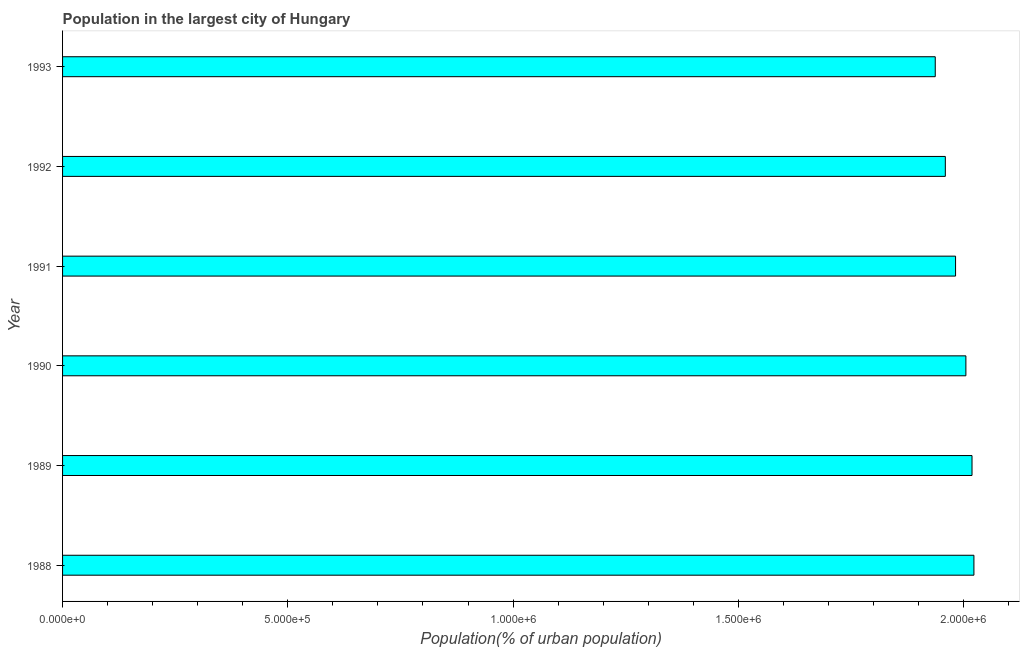Does the graph contain any zero values?
Offer a very short reply. No. Does the graph contain grids?
Ensure brevity in your answer.  No. What is the title of the graph?
Provide a succinct answer. Population in the largest city of Hungary. What is the label or title of the X-axis?
Give a very brief answer. Population(% of urban population). What is the population in largest city in 1991?
Your answer should be very brief. 1.98e+06. Across all years, what is the maximum population in largest city?
Offer a terse response. 2.02e+06. Across all years, what is the minimum population in largest city?
Offer a terse response. 1.94e+06. In which year was the population in largest city minimum?
Offer a terse response. 1993. What is the sum of the population in largest city?
Your response must be concise. 1.19e+07. What is the difference between the population in largest city in 1991 and 1992?
Your answer should be very brief. 2.27e+04. What is the average population in largest city per year?
Give a very brief answer. 1.99e+06. What is the median population in largest city?
Give a very brief answer. 1.99e+06. Do a majority of the years between 1992 and 1988 (inclusive) have population in largest city greater than 1700000 %?
Keep it short and to the point. Yes. Is the population in largest city in 1989 less than that in 1992?
Your answer should be compact. No. What is the difference between the highest and the second highest population in largest city?
Make the answer very short. 4225. Is the sum of the population in largest city in 1988 and 1991 greater than the maximum population in largest city across all years?
Ensure brevity in your answer.  Yes. What is the difference between the highest and the lowest population in largest city?
Your answer should be very brief. 8.59e+04. In how many years, is the population in largest city greater than the average population in largest city taken over all years?
Your answer should be very brief. 3. How many bars are there?
Give a very brief answer. 6. Are all the bars in the graph horizontal?
Your answer should be compact. Yes. How many years are there in the graph?
Offer a terse response. 6. What is the difference between two consecutive major ticks on the X-axis?
Ensure brevity in your answer.  5.00e+05. What is the Population(% of urban population) in 1988?
Provide a succinct answer. 2.02e+06. What is the Population(% of urban population) of 1989?
Provide a succinct answer. 2.02e+06. What is the Population(% of urban population) in 1990?
Give a very brief answer. 2.01e+06. What is the Population(% of urban population) of 1991?
Make the answer very short. 1.98e+06. What is the Population(% of urban population) in 1992?
Offer a terse response. 1.96e+06. What is the Population(% of urban population) in 1993?
Your answer should be compact. 1.94e+06. What is the difference between the Population(% of urban population) in 1988 and 1989?
Ensure brevity in your answer.  4225. What is the difference between the Population(% of urban population) in 1988 and 1990?
Offer a terse response. 1.78e+04. What is the difference between the Population(% of urban population) in 1988 and 1991?
Your answer should be very brief. 4.08e+04. What is the difference between the Population(% of urban population) in 1988 and 1992?
Your answer should be very brief. 6.35e+04. What is the difference between the Population(% of urban population) in 1988 and 1993?
Make the answer very short. 8.59e+04. What is the difference between the Population(% of urban population) in 1989 and 1990?
Offer a terse response. 1.36e+04. What is the difference between the Population(% of urban population) in 1989 and 1991?
Offer a very short reply. 3.65e+04. What is the difference between the Population(% of urban population) in 1989 and 1992?
Provide a succinct answer. 5.92e+04. What is the difference between the Population(% of urban population) in 1989 and 1993?
Offer a terse response. 8.16e+04. What is the difference between the Population(% of urban population) in 1990 and 1991?
Offer a terse response. 2.29e+04. What is the difference between the Population(% of urban population) in 1990 and 1992?
Keep it short and to the point. 4.56e+04. What is the difference between the Population(% of urban population) in 1990 and 1993?
Provide a short and direct response. 6.80e+04. What is the difference between the Population(% of urban population) in 1991 and 1992?
Offer a very short reply. 2.27e+04. What is the difference between the Population(% of urban population) in 1991 and 1993?
Your answer should be very brief. 4.51e+04. What is the difference between the Population(% of urban population) in 1992 and 1993?
Give a very brief answer. 2.24e+04. What is the ratio of the Population(% of urban population) in 1988 to that in 1992?
Offer a very short reply. 1.03. What is the ratio of the Population(% of urban population) in 1988 to that in 1993?
Offer a very short reply. 1.04. What is the ratio of the Population(% of urban population) in 1989 to that in 1990?
Your answer should be compact. 1.01. What is the ratio of the Population(% of urban population) in 1989 to that in 1992?
Give a very brief answer. 1.03. What is the ratio of the Population(% of urban population) in 1989 to that in 1993?
Offer a terse response. 1.04. What is the ratio of the Population(% of urban population) in 1990 to that in 1991?
Make the answer very short. 1.01. What is the ratio of the Population(% of urban population) in 1990 to that in 1992?
Keep it short and to the point. 1.02. What is the ratio of the Population(% of urban population) in 1990 to that in 1993?
Offer a terse response. 1.03. What is the ratio of the Population(% of urban population) in 1992 to that in 1993?
Offer a very short reply. 1.01. 